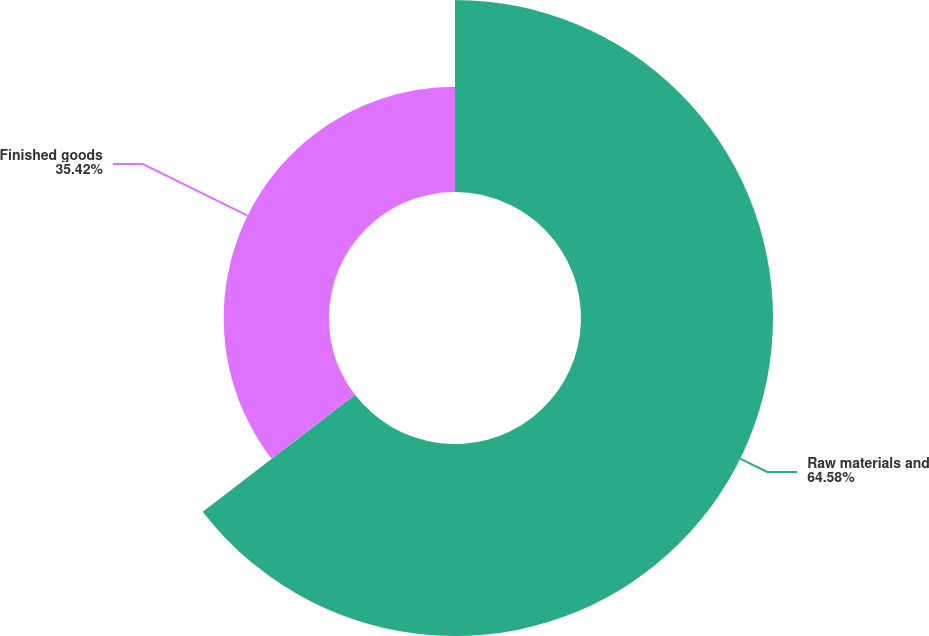<chart> <loc_0><loc_0><loc_500><loc_500><pie_chart><fcel>Raw materials and<fcel>Finished goods<nl><fcel>64.58%<fcel>35.42%<nl></chart> 